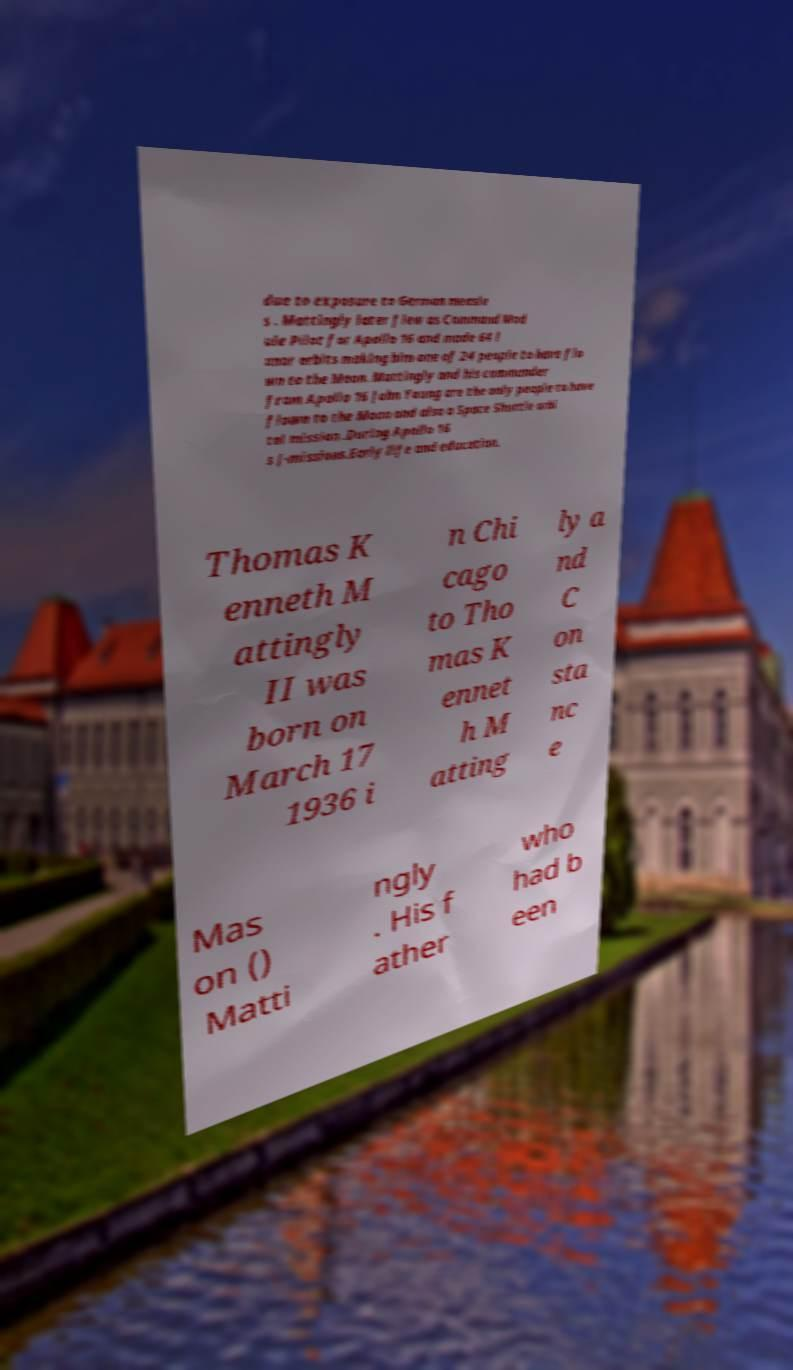Can you read and provide the text displayed in the image?This photo seems to have some interesting text. Can you extract and type it out for me? due to exposure to German measle s . Mattingly later flew as Command Mod ule Pilot for Apollo 16 and made 64 l unar orbits making him one of 24 people to have flo wn to the Moon. Mattingly and his commander from Apollo 16 John Young are the only people to have flown to the Moon and also a Space Shuttle orbi tal mission .During Apollo 16 s J-missions.Early life and education. Thomas K enneth M attingly II was born on March 17 1936 i n Chi cago to Tho mas K ennet h M atting ly a nd C on sta nc e Mas on () Matti ngly . His f ather who had b een 